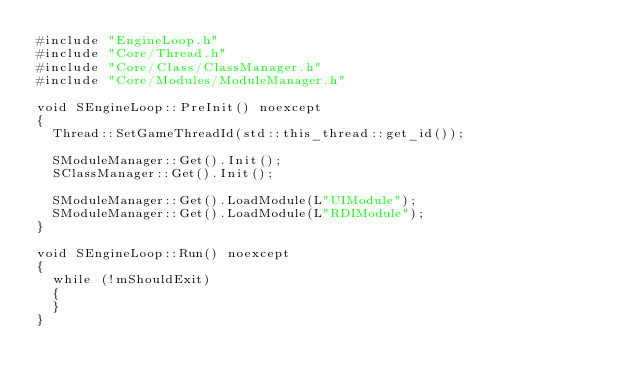Convert code to text. <code><loc_0><loc_0><loc_500><loc_500><_C++_>#include "EngineLoop.h"
#include "Core/Thread.h"
#include "Core/Class/ClassManager.h"
#include "Core/Modules/ModuleManager.h"

void SEngineLoop::PreInit() noexcept
{
	Thread::SetGameThreadId(std::this_thread::get_id());

	SModuleManager::Get().Init();
	SClassManager::Get().Init();

	SModuleManager::Get().LoadModule(L"UIModule");
	SModuleManager::Get().LoadModule(L"RDIModule");
}

void SEngineLoop::Run() noexcept
{
	while (!mShouldExit)
	{
	}
}
</code> 